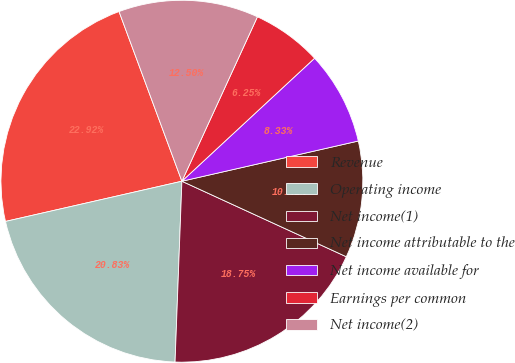<chart> <loc_0><loc_0><loc_500><loc_500><pie_chart><fcel>Revenue<fcel>Operating income<fcel>Net income(1)<fcel>Net income attributable to the<fcel>Net income available for<fcel>Earnings per common<fcel>Net income(2)<nl><fcel>22.92%<fcel>20.83%<fcel>18.75%<fcel>10.42%<fcel>8.33%<fcel>6.25%<fcel>12.5%<nl></chart> 